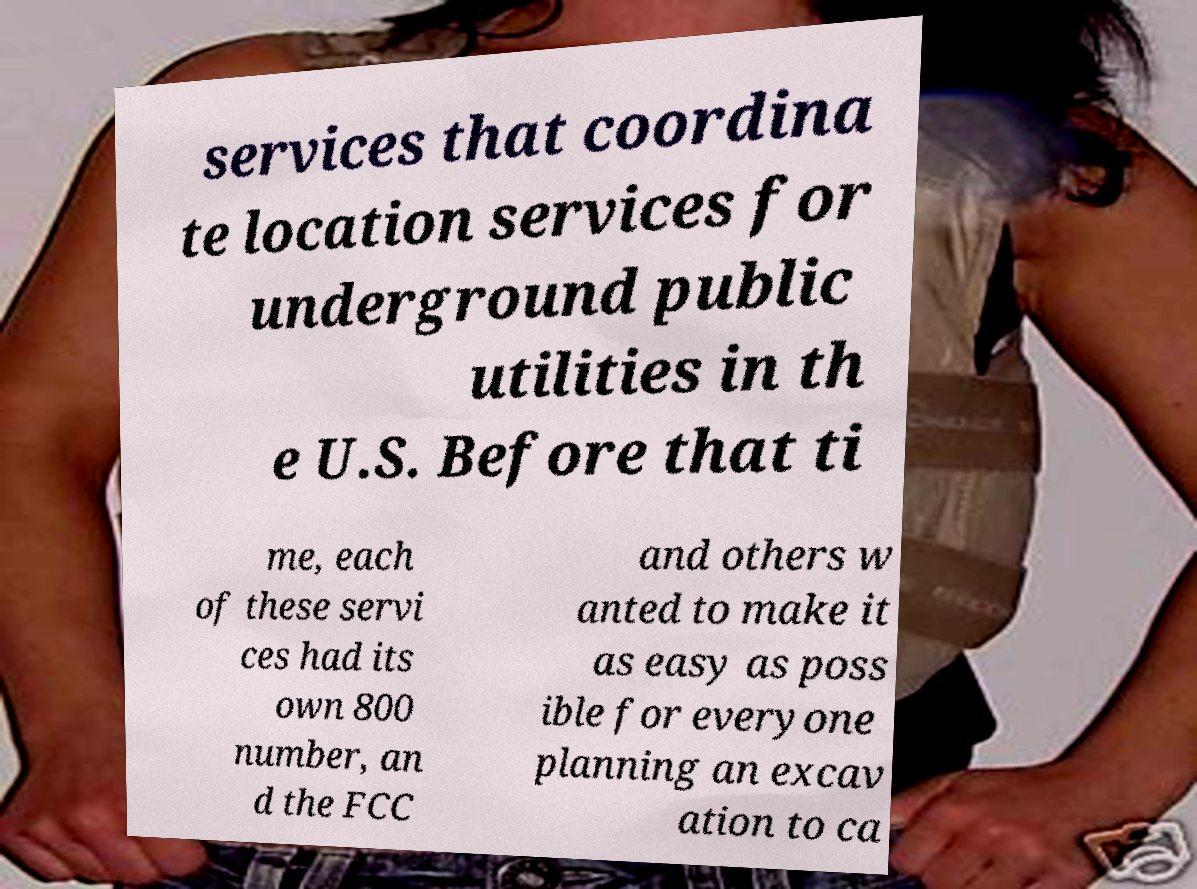I need the written content from this picture converted into text. Can you do that? services that coordina te location services for underground public utilities in th e U.S. Before that ti me, each of these servi ces had its own 800 number, an d the FCC and others w anted to make it as easy as poss ible for everyone planning an excav ation to ca 